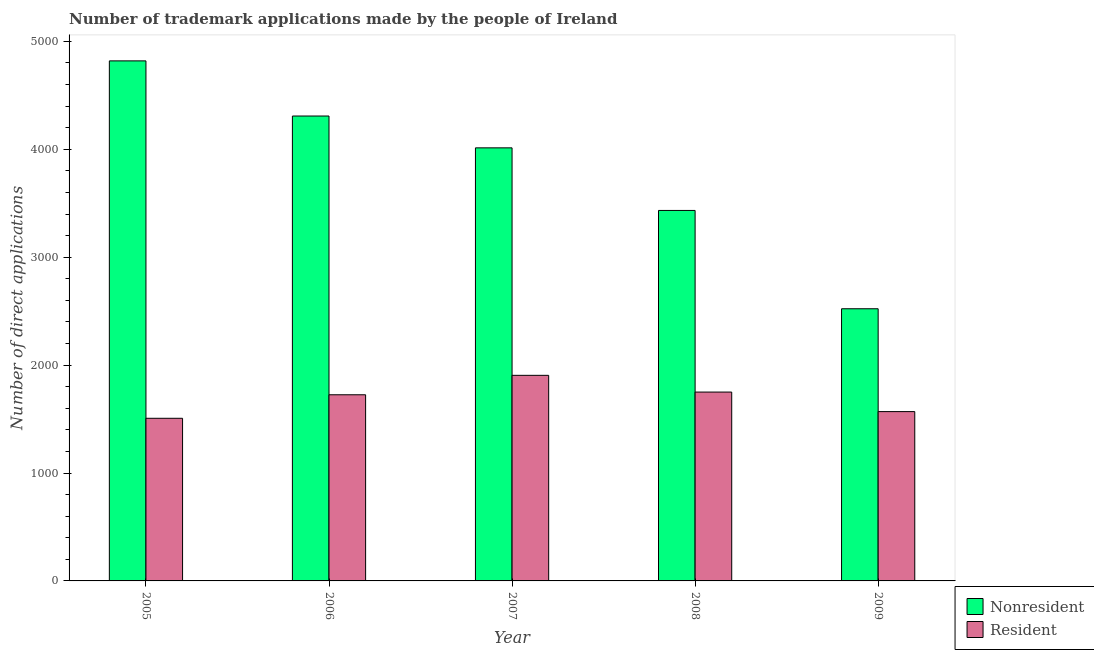How many groups of bars are there?
Give a very brief answer. 5. Are the number of bars on each tick of the X-axis equal?
Your answer should be compact. Yes. What is the label of the 5th group of bars from the left?
Your response must be concise. 2009. What is the number of trademark applications made by residents in 2008?
Make the answer very short. 1750. Across all years, what is the maximum number of trademark applications made by residents?
Give a very brief answer. 1905. Across all years, what is the minimum number of trademark applications made by residents?
Give a very brief answer. 1507. In which year was the number of trademark applications made by non residents maximum?
Provide a short and direct response. 2005. In which year was the number of trademark applications made by residents minimum?
Your answer should be compact. 2005. What is the total number of trademark applications made by non residents in the graph?
Offer a terse response. 1.91e+04. What is the difference between the number of trademark applications made by non residents in 2006 and that in 2009?
Keep it short and to the point. 1786. What is the difference between the number of trademark applications made by residents in 2005 and the number of trademark applications made by non residents in 2007?
Provide a short and direct response. -398. What is the average number of trademark applications made by residents per year?
Ensure brevity in your answer.  1691.2. What is the ratio of the number of trademark applications made by non residents in 2005 to that in 2009?
Offer a terse response. 1.91. Is the number of trademark applications made by residents in 2005 less than that in 2009?
Your response must be concise. Yes. Is the difference between the number of trademark applications made by non residents in 2005 and 2007 greater than the difference between the number of trademark applications made by residents in 2005 and 2007?
Offer a terse response. No. What is the difference between the highest and the second highest number of trademark applications made by non residents?
Keep it short and to the point. 511. What is the difference between the highest and the lowest number of trademark applications made by residents?
Your answer should be very brief. 398. What does the 1st bar from the left in 2005 represents?
Make the answer very short. Nonresident. What does the 1st bar from the right in 2007 represents?
Keep it short and to the point. Resident. Are all the bars in the graph horizontal?
Make the answer very short. No. Are the values on the major ticks of Y-axis written in scientific E-notation?
Give a very brief answer. No. Does the graph contain any zero values?
Make the answer very short. No. Does the graph contain grids?
Ensure brevity in your answer.  No. Where does the legend appear in the graph?
Your answer should be compact. Bottom right. What is the title of the graph?
Offer a very short reply. Number of trademark applications made by the people of Ireland. Does "Stunting" appear as one of the legend labels in the graph?
Offer a terse response. No. What is the label or title of the Y-axis?
Keep it short and to the point. Number of direct applications. What is the Number of direct applications in Nonresident in 2005?
Offer a very short reply. 4819. What is the Number of direct applications of Resident in 2005?
Keep it short and to the point. 1507. What is the Number of direct applications in Nonresident in 2006?
Your response must be concise. 4308. What is the Number of direct applications of Resident in 2006?
Ensure brevity in your answer.  1725. What is the Number of direct applications in Nonresident in 2007?
Make the answer very short. 4013. What is the Number of direct applications in Resident in 2007?
Give a very brief answer. 1905. What is the Number of direct applications in Nonresident in 2008?
Keep it short and to the point. 3433. What is the Number of direct applications in Resident in 2008?
Keep it short and to the point. 1750. What is the Number of direct applications of Nonresident in 2009?
Keep it short and to the point. 2522. What is the Number of direct applications in Resident in 2009?
Provide a short and direct response. 1569. Across all years, what is the maximum Number of direct applications in Nonresident?
Your response must be concise. 4819. Across all years, what is the maximum Number of direct applications of Resident?
Provide a succinct answer. 1905. Across all years, what is the minimum Number of direct applications in Nonresident?
Offer a very short reply. 2522. Across all years, what is the minimum Number of direct applications of Resident?
Ensure brevity in your answer.  1507. What is the total Number of direct applications in Nonresident in the graph?
Give a very brief answer. 1.91e+04. What is the total Number of direct applications in Resident in the graph?
Provide a succinct answer. 8456. What is the difference between the Number of direct applications in Nonresident in 2005 and that in 2006?
Your answer should be compact. 511. What is the difference between the Number of direct applications of Resident in 2005 and that in 2006?
Keep it short and to the point. -218. What is the difference between the Number of direct applications in Nonresident in 2005 and that in 2007?
Your answer should be very brief. 806. What is the difference between the Number of direct applications in Resident in 2005 and that in 2007?
Provide a short and direct response. -398. What is the difference between the Number of direct applications of Nonresident in 2005 and that in 2008?
Your answer should be compact. 1386. What is the difference between the Number of direct applications in Resident in 2005 and that in 2008?
Make the answer very short. -243. What is the difference between the Number of direct applications in Nonresident in 2005 and that in 2009?
Your answer should be compact. 2297. What is the difference between the Number of direct applications of Resident in 2005 and that in 2009?
Make the answer very short. -62. What is the difference between the Number of direct applications in Nonresident in 2006 and that in 2007?
Provide a succinct answer. 295. What is the difference between the Number of direct applications in Resident in 2006 and that in 2007?
Give a very brief answer. -180. What is the difference between the Number of direct applications in Nonresident in 2006 and that in 2008?
Make the answer very short. 875. What is the difference between the Number of direct applications in Resident in 2006 and that in 2008?
Provide a short and direct response. -25. What is the difference between the Number of direct applications of Nonresident in 2006 and that in 2009?
Give a very brief answer. 1786. What is the difference between the Number of direct applications in Resident in 2006 and that in 2009?
Provide a succinct answer. 156. What is the difference between the Number of direct applications of Nonresident in 2007 and that in 2008?
Give a very brief answer. 580. What is the difference between the Number of direct applications in Resident in 2007 and that in 2008?
Give a very brief answer. 155. What is the difference between the Number of direct applications in Nonresident in 2007 and that in 2009?
Offer a very short reply. 1491. What is the difference between the Number of direct applications in Resident in 2007 and that in 2009?
Your answer should be very brief. 336. What is the difference between the Number of direct applications of Nonresident in 2008 and that in 2009?
Give a very brief answer. 911. What is the difference between the Number of direct applications in Resident in 2008 and that in 2009?
Provide a short and direct response. 181. What is the difference between the Number of direct applications of Nonresident in 2005 and the Number of direct applications of Resident in 2006?
Make the answer very short. 3094. What is the difference between the Number of direct applications of Nonresident in 2005 and the Number of direct applications of Resident in 2007?
Ensure brevity in your answer.  2914. What is the difference between the Number of direct applications in Nonresident in 2005 and the Number of direct applications in Resident in 2008?
Make the answer very short. 3069. What is the difference between the Number of direct applications in Nonresident in 2005 and the Number of direct applications in Resident in 2009?
Offer a very short reply. 3250. What is the difference between the Number of direct applications in Nonresident in 2006 and the Number of direct applications in Resident in 2007?
Keep it short and to the point. 2403. What is the difference between the Number of direct applications in Nonresident in 2006 and the Number of direct applications in Resident in 2008?
Ensure brevity in your answer.  2558. What is the difference between the Number of direct applications of Nonresident in 2006 and the Number of direct applications of Resident in 2009?
Ensure brevity in your answer.  2739. What is the difference between the Number of direct applications of Nonresident in 2007 and the Number of direct applications of Resident in 2008?
Provide a succinct answer. 2263. What is the difference between the Number of direct applications in Nonresident in 2007 and the Number of direct applications in Resident in 2009?
Make the answer very short. 2444. What is the difference between the Number of direct applications in Nonresident in 2008 and the Number of direct applications in Resident in 2009?
Your response must be concise. 1864. What is the average Number of direct applications in Nonresident per year?
Make the answer very short. 3819. What is the average Number of direct applications of Resident per year?
Ensure brevity in your answer.  1691.2. In the year 2005, what is the difference between the Number of direct applications in Nonresident and Number of direct applications in Resident?
Offer a very short reply. 3312. In the year 2006, what is the difference between the Number of direct applications of Nonresident and Number of direct applications of Resident?
Ensure brevity in your answer.  2583. In the year 2007, what is the difference between the Number of direct applications in Nonresident and Number of direct applications in Resident?
Provide a succinct answer. 2108. In the year 2008, what is the difference between the Number of direct applications of Nonresident and Number of direct applications of Resident?
Offer a very short reply. 1683. In the year 2009, what is the difference between the Number of direct applications in Nonresident and Number of direct applications in Resident?
Offer a very short reply. 953. What is the ratio of the Number of direct applications of Nonresident in 2005 to that in 2006?
Ensure brevity in your answer.  1.12. What is the ratio of the Number of direct applications in Resident in 2005 to that in 2006?
Provide a succinct answer. 0.87. What is the ratio of the Number of direct applications in Nonresident in 2005 to that in 2007?
Your response must be concise. 1.2. What is the ratio of the Number of direct applications of Resident in 2005 to that in 2007?
Provide a succinct answer. 0.79. What is the ratio of the Number of direct applications of Nonresident in 2005 to that in 2008?
Provide a succinct answer. 1.4. What is the ratio of the Number of direct applications of Resident in 2005 to that in 2008?
Your answer should be compact. 0.86. What is the ratio of the Number of direct applications in Nonresident in 2005 to that in 2009?
Give a very brief answer. 1.91. What is the ratio of the Number of direct applications in Resident in 2005 to that in 2009?
Offer a terse response. 0.96. What is the ratio of the Number of direct applications in Nonresident in 2006 to that in 2007?
Your response must be concise. 1.07. What is the ratio of the Number of direct applications in Resident in 2006 to that in 2007?
Your response must be concise. 0.91. What is the ratio of the Number of direct applications in Nonresident in 2006 to that in 2008?
Offer a terse response. 1.25. What is the ratio of the Number of direct applications in Resident in 2006 to that in 2008?
Your answer should be compact. 0.99. What is the ratio of the Number of direct applications of Nonresident in 2006 to that in 2009?
Your answer should be very brief. 1.71. What is the ratio of the Number of direct applications in Resident in 2006 to that in 2009?
Your answer should be very brief. 1.1. What is the ratio of the Number of direct applications of Nonresident in 2007 to that in 2008?
Offer a terse response. 1.17. What is the ratio of the Number of direct applications in Resident in 2007 to that in 2008?
Your answer should be very brief. 1.09. What is the ratio of the Number of direct applications of Nonresident in 2007 to that in 2009?
Provide a short and direct response. 1.59. What is the ratio of the Number of direct applications of Resident in 2007 to that in 2009?
Your answer should be very brief. 1.21. What is the ratio of the Number of direct applications in Nonresident in 2008 to that in 2009?
Give a very brief answer. 1.36. What is the ratio of the Number of direct applications in Resident in 2008 to that in 2009?
Give a very brief answer. 1.12. What is the difference between the highest and the second highest Number of direct applications of Nonresident?
Provide a short and direct response. 511. What is the difference between the highest and the second highest Number of direct applications of Resident?
Offer a very short reply. 155. What is the difference between the highest and the lowest Number of direct applications of Nonresident?
Your answer should be very brief. 2297. What is the difference between the highest and the lowest Number of direct applications in Resident?
Provide a succinct answer. 398. 